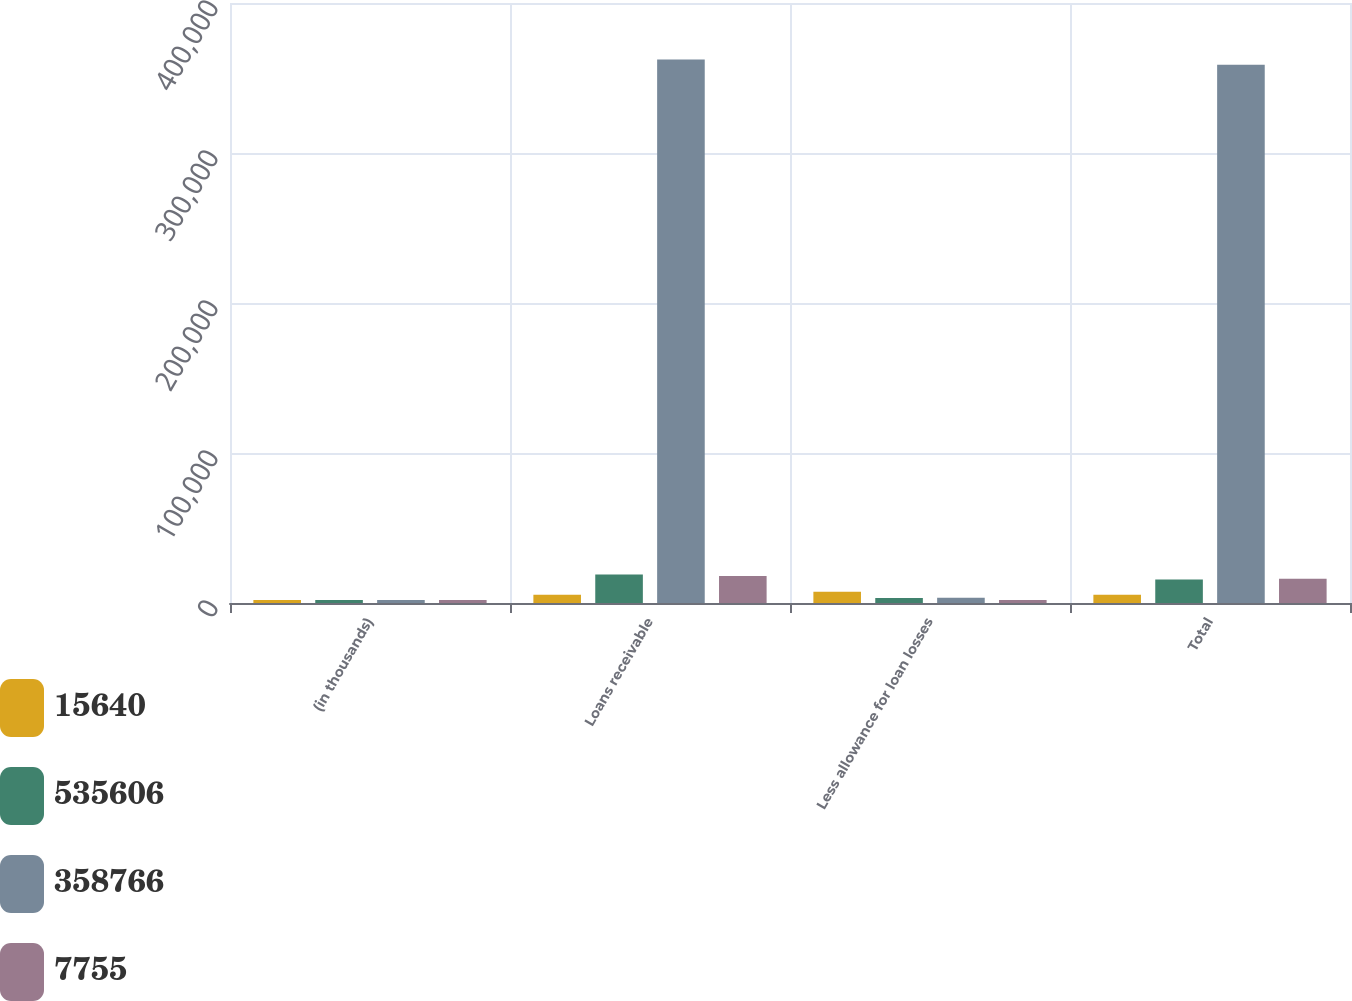<chart> <loc_0><loc_0><loc_500><loc_500><stacked_bar_chart><ecel><fcel>(in thousands)<fcel>Loans receivable<fcel>Less allowance for loan losses<fcel>Total<nl><fcel>15640<fcel>2011<fcel>5549.5<fcel>7570<fcel>5549.5<nl><fcel>535606<fcel>2011<fcel>18964<fcel>3324<fcel>15640<nl><fcel>358766<fcel>2010<fcel>362295<fcel>3529<fcel>358766<nl><fcel>7755<fcel>2010<fcel>18040<fcel>1920<fcel>16120<nl></chart> 